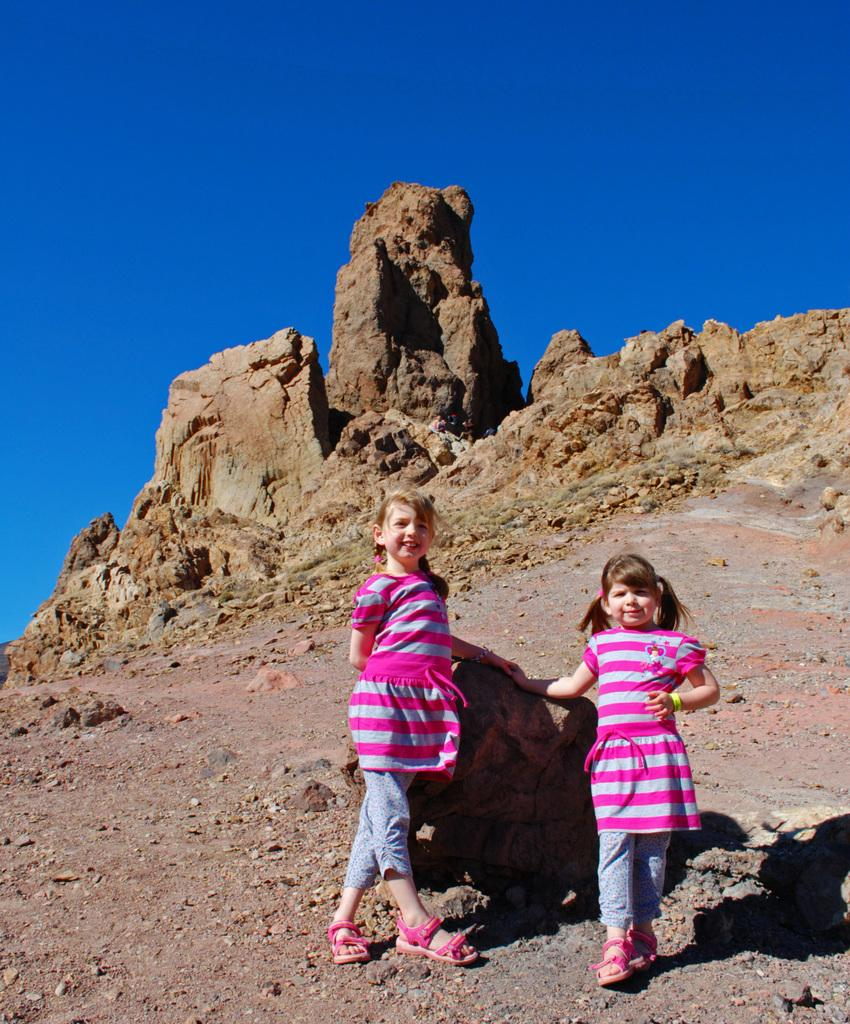How many girls are in the image? There are two girls in the image. What are the girls wearing? Both girls are wearing pink dresses and pink sandals. What else can be seen in the image besides the girls? There are shadows, stones, and the sky visible in the image. What type of potato is being used as a swing in the image? There is no potato or swing present in the image. How are the girls caring for the stones in the image? The girls are not shown caring for the stones in the image; they are simply standing near them. 